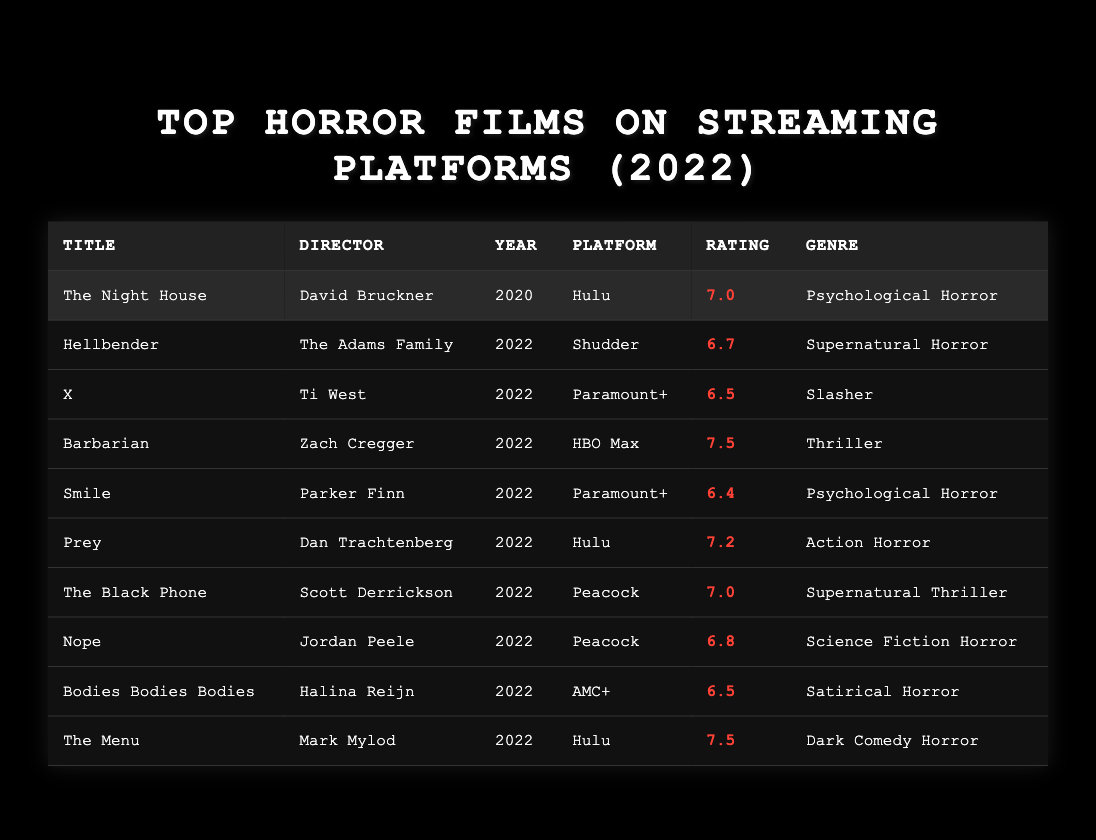What is the highest viewer rating among the listed films? Looking at the viewer ratings in the table, "Barbarian" and "The Menu" both have the highest rating of 7.5.
Answer: 7.5 Which film directed by David Bruckner is listed? The table shows "The Night House," directed by David Bruckner, under the films section.
Answer: The Night House How many films have a viewer rating of 7.0? There are two films with a viewer rating of 7.0: "The Night House" and "The Black Phone."
Answer: 2 What platforms are the films "Smile" and "X" available on? "Smile" is available on Paramount+, and "X" is also available on Paramount+.
Answer: Paramount+ What is the average viewer rating of the films listed? To find the average, sum all the ratings: (7.0 + 6.7 + 6.5 + 7.5 + 6.4 + 7.2 + 7.0 + 6.8 + 6.5 + 7.5) = 69.7. There are 10 films, so the average rating is 69.7 / 10 = 6.97.
Answer: 6.97 Is "Hellbender" rated higher than "Smile"? "Hellbender" has a rating of 6.7, while "Smile" has a rating of 6.4, so "Hellbender" is rated higher.
Answer: Yes What genre does "Prey" belong to? The table indicates that "Prey" is categorized as "Action Horror."
Answer: Action Horror Which film has a viewer rating closest to 6.5? The films "X" and "Bodies Bodies Bodies" both have a rating of 6.5, which is the closest rating to 6.5 itself.
Answer: X and Bodies Bodies Bodies How many films have a viewer rating below 7.0? The ratings below 7.0 are for "Hellbender" (6.7), "X" (6.5), "Smile" (6.4), "Nope" (6.8), and "Bodies Bodies Bodies" (6.5), totaling 5 films.
Answer: 5 What is the viewer rating difference between "Barbarian" and "The Night House"? "Barbarian" has a rating of 7.5 and "The Night House" has a rating of 7.0. The difference is 7.5 - 7.0 = 0.5.
Answer: 0.5 